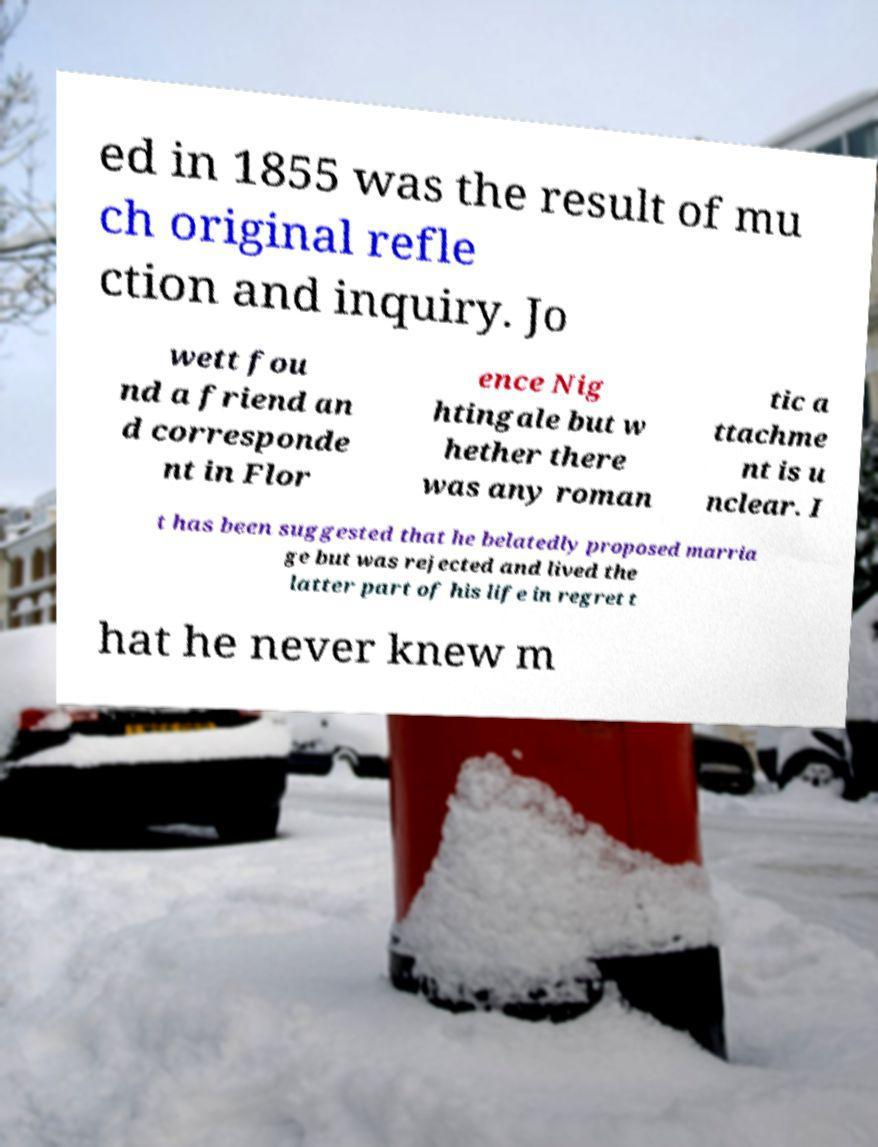Please identify and transcribe the text found in this image. ed in 1855 was the result of mu ch original refle ction and inquiry. Jo wett fou nd a friend an d corresponde nt in Flor ence Nig htingale but w hether there was any roman tic a ttachme nt is u nclear. I t has been suggested that he belatedly proposed marria ge but was rejected and lived the latter part of his life in regret t hat he never knew m 